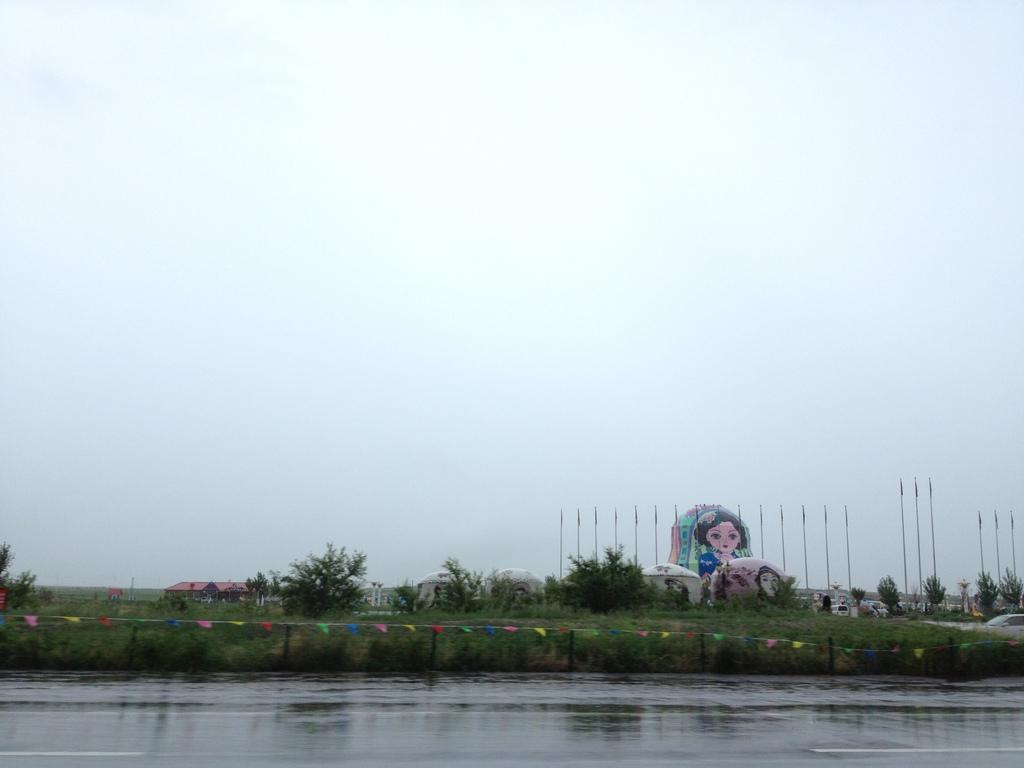What is the primary element visible in the image? There is water in the image. What type of terrain can be seen in the image? There is ground visible in the image, along with grass. What structures are present in the image? There are poles, houses, and possibly art on objects in the image. What type of vegetation is present in the image? There are trees in the image. What else is visible in the image? There are small flags and the sky is visible in the image. What type of insurance does the dad in the image have? There is no dad present in the image, and therefore no insurance information can be provided. 